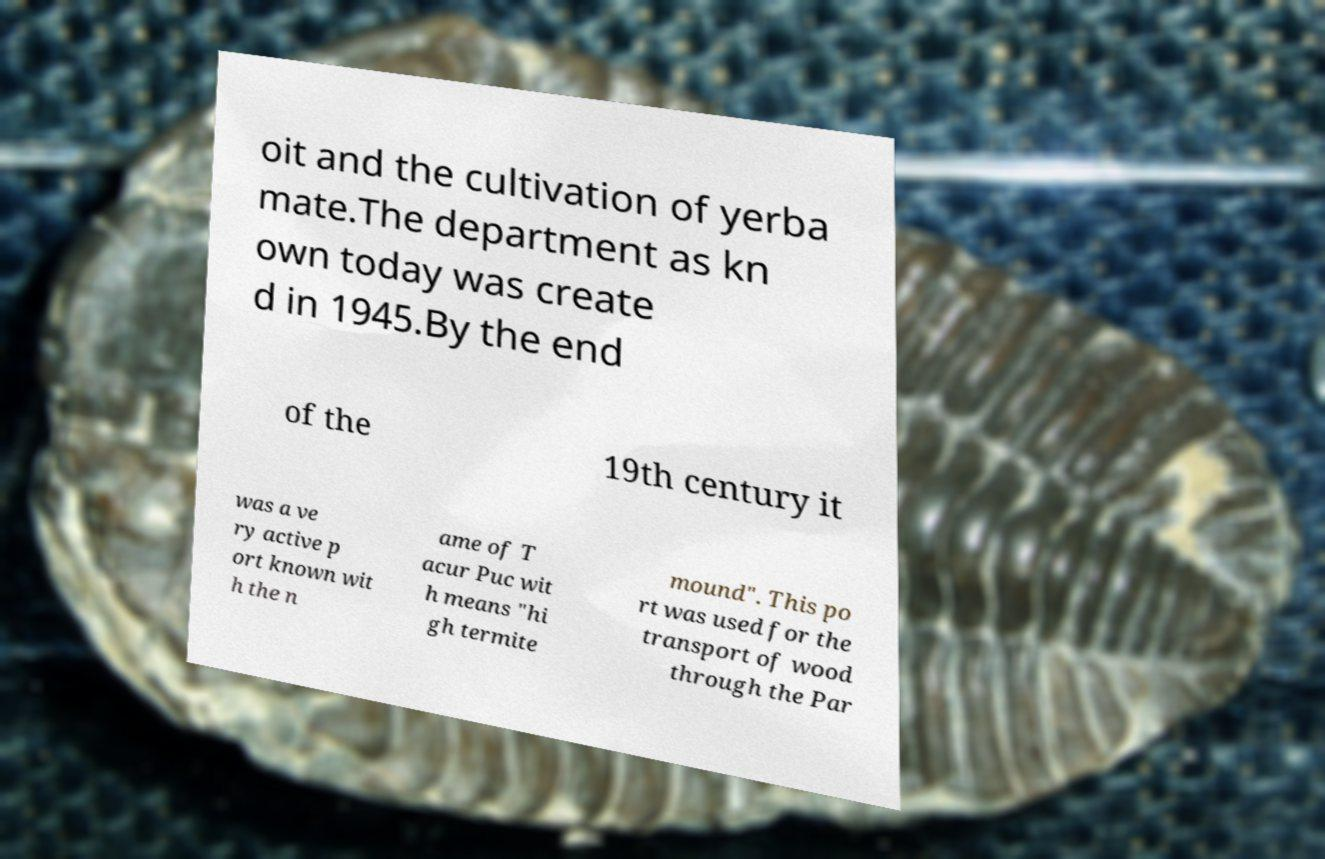Can you accurately transcribe the text from the provided image for me? oit and the cultivation of yerba mate.The department as kn own today was create d in 1945.By the end of the 19th century it was a ve ry active p ort known wit h the n ame of T acur Puc wit h means "hi gh termite mound". This po rt was used for the transport of wood through the Par 